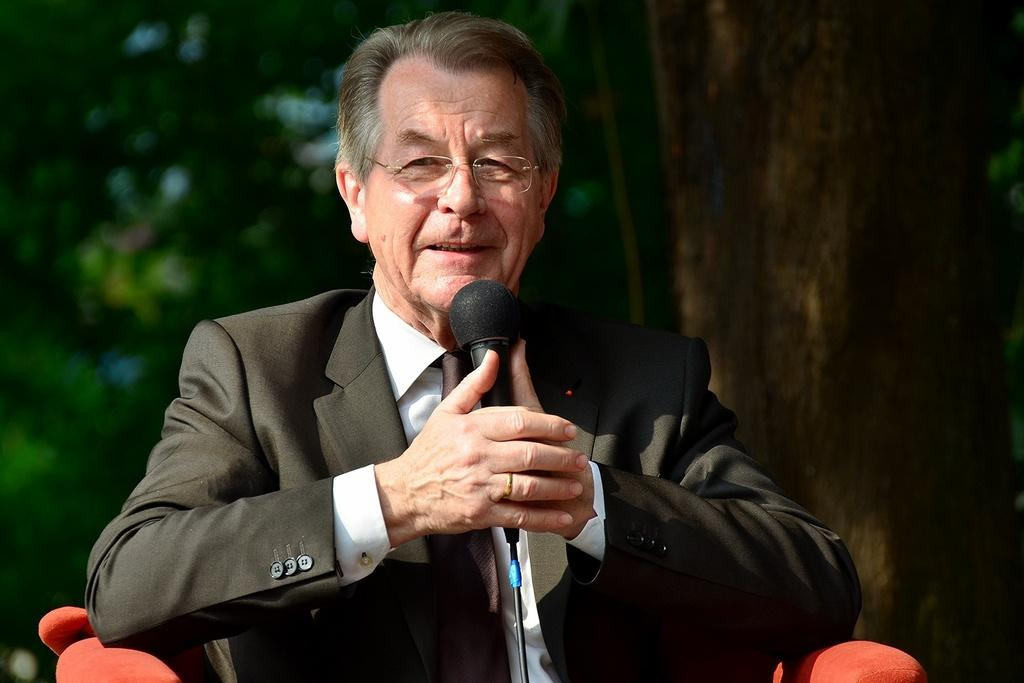What is the man in the image doing? The man is sitting in the image. What object is the man holding? The man is holding a microphone. What can be seen in the background of the image? There is a tree in the background of the image. What type of story can be heard coming from the faucet in the image? There is no faucet present in the image, so it's not possible to determine what, if any, story might be heard coming from a faucet. 